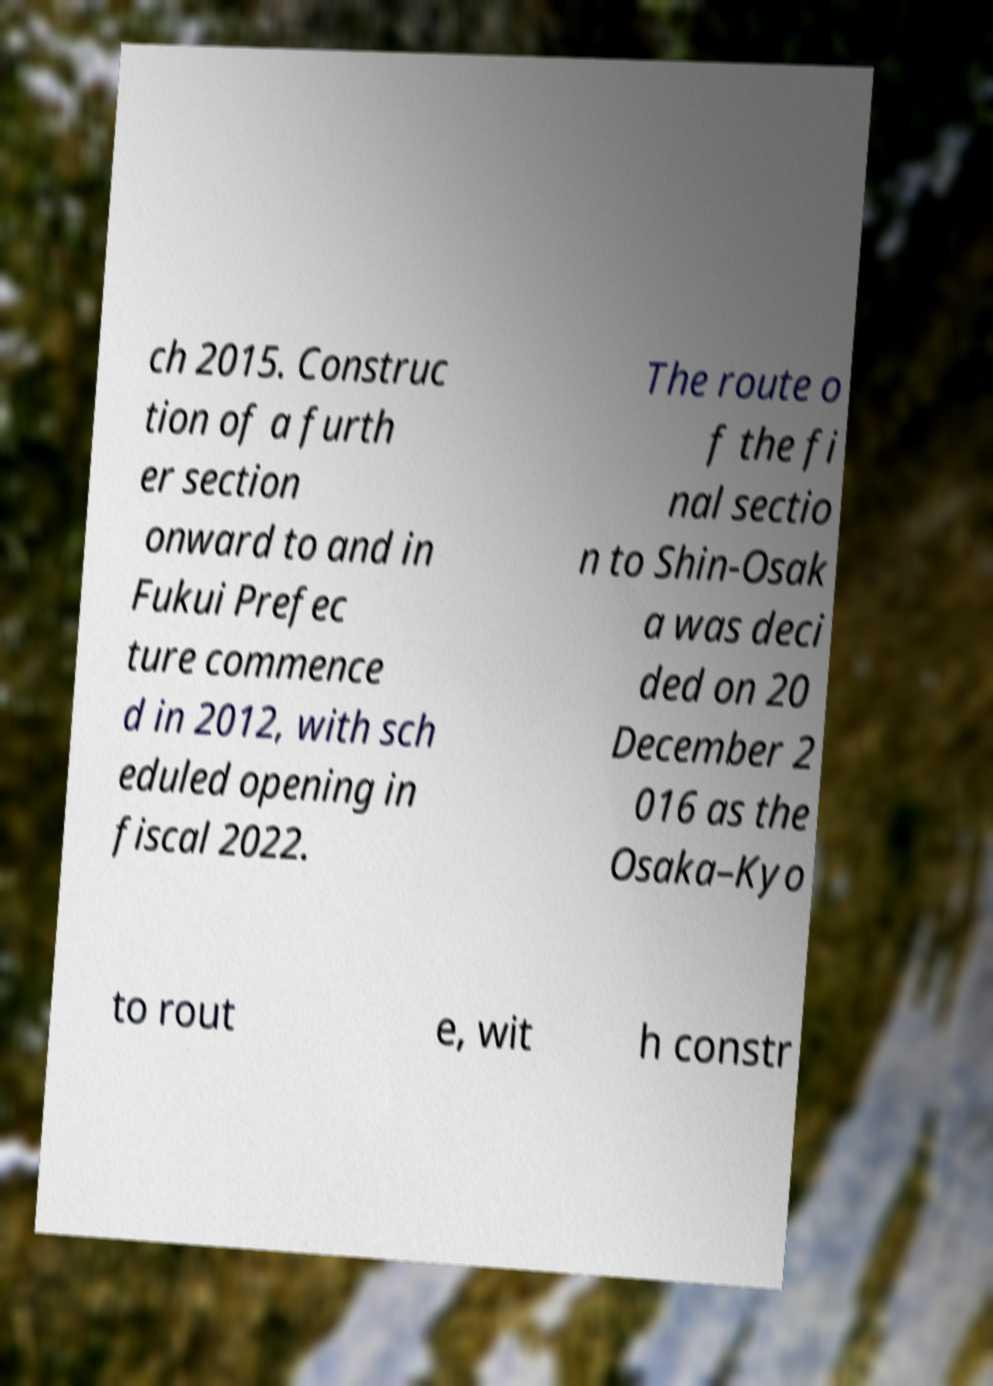Can you accurately transcribe the text from the provided image for me? ch 2015. Construc tion of a furth er section onward to and in Fukui Prefec ture commence d in 2012, with sch eduled opening in fiscal 2022. The route o f the fi nal sectio n to Shin-Osak a was deci ded on 20 December 2 016 as the Osaka–Kyo to rout e, wit h constr 